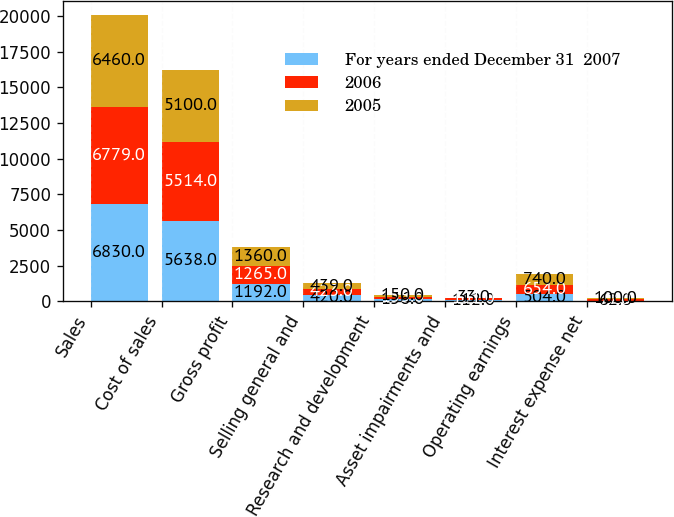Convert chart to OTSL. <chart><loc_0><loc_0><loc_500><loc_500><stacked_bar_chart><ecel><fcel>Sales<fcel>Cost of sales<fcel>Gross profit<fcel>Selling general and<fcel>Research and development<fcel>Asset impairments and<fcel>Operating earnings<fcel>Interest expense net<nl><fcel>For years ended December 31  2007<fcel>6830<fcel>5638<fcel>1192<fcel>420<fcel>156<fcel>112<fcel>504<fcel>62<nl><fcel>2006<fcel>6779<fcel>5514<fcel>1265<fcel>423<fcel>155<fcel>101<fcel>654<fcel>77<nl><fcel>2005<fcel>6460<fcel>5100<fcel>1360<fcel>439<fcel>150<fcel>33<fcel>740<fcel>100<nl></chart> 